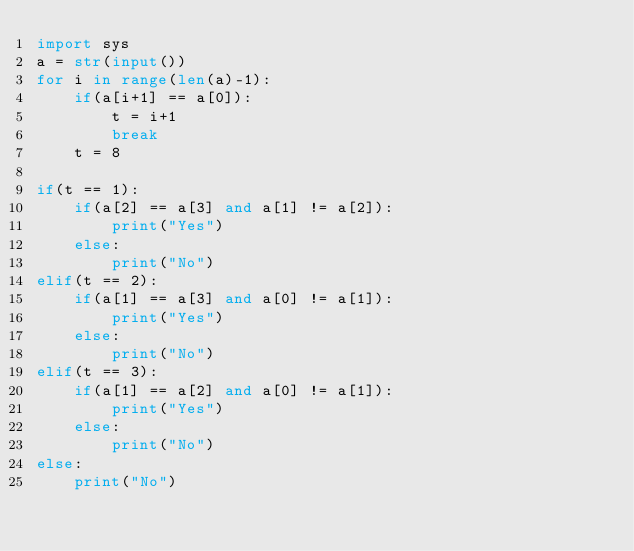Convert code to text. <code><loc_0><loc_0><loc_500><loc_500><_Python_>import sys
a = str(input())
for i in range(len(a)-1):
    if(a[i+1] == a[0]):
        t = i+1
        break
    t = 8

if(t == 1):
    if(a[2] == a[3] and a[1] != a[2]):
        print("Yes")
    else:
        print("No")
elif(t == 2):
    if(a[1] == a[3] and a[0] != a[1]):
        print("Yes")
    else:
        print("No")
elif(t == 3):
    if(a[1] == a[2] and a[0] != a[1]):
        print("Yes")
    else:
        print("No")
else:
    print("No")</code> 